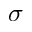<formula> <loc_0><loc_0><loc_500><loc_500>\sigma</formula> 